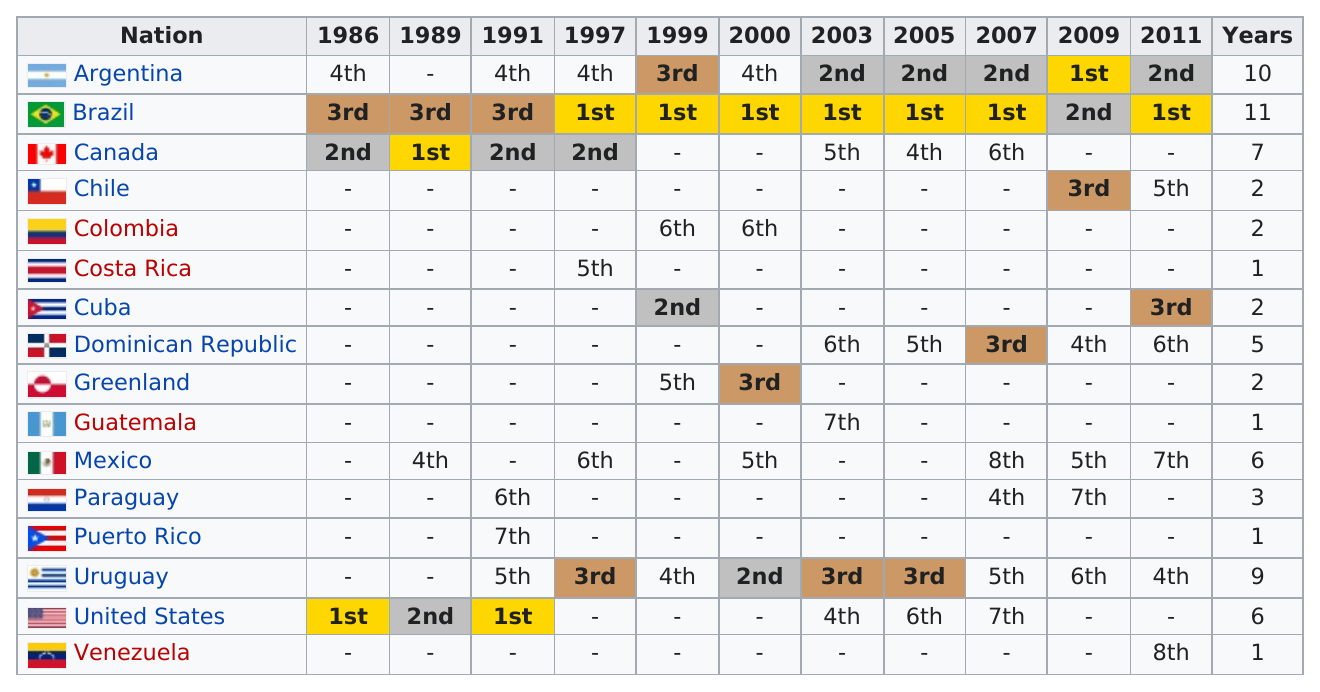Point out several critical features in this image. Argentina and Brazil have combined for a total of 21 years in which they have placed in the top 4 or above in the FIFA World Cup. Greenland placed fifth in 1999, and the following year, they ranked third. In 2009, Argentina was the top competitor. Brazil has been in first place seven times. There are six nations that have placed more than five different years in the Olympic Games. 